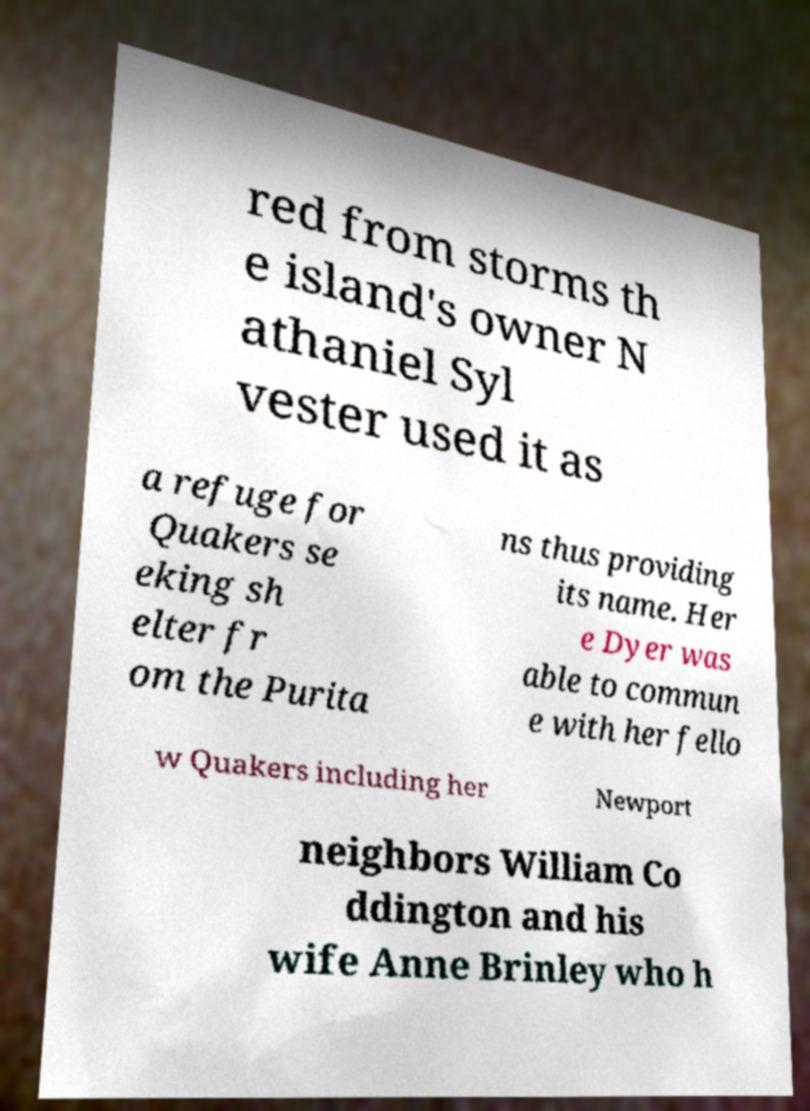Please identify and transcribe the text found in this image. red from storms th e island's owner N athaniel Syl vester used it as a refuge for Quakers se eking sh elter fr om the Purita ns thus providing its name. Her e Dyer was able to commun e with her fello w Quakers including her Newport neighbors William Co ddington and his wife Anne Brinley who h 